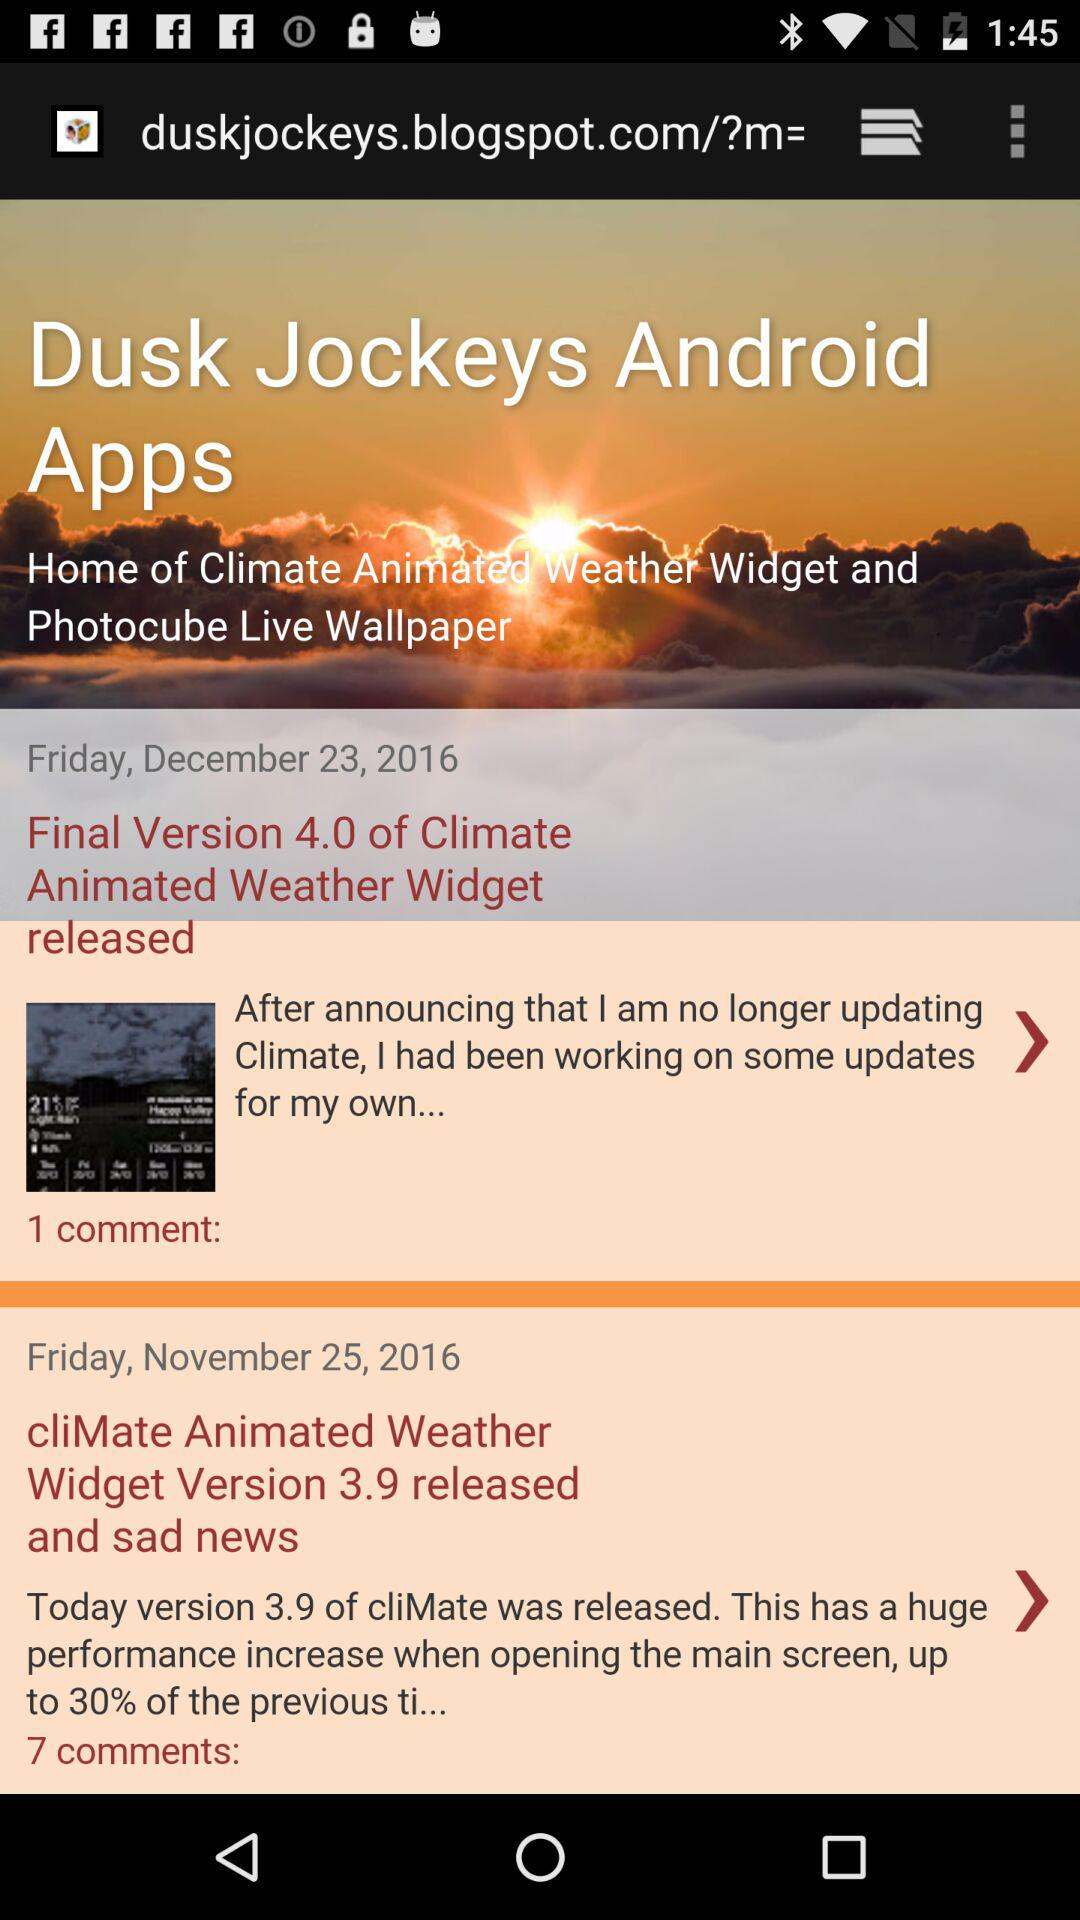How many comments does the first blog post have?
Answer the question using a single word or phrase. 1 